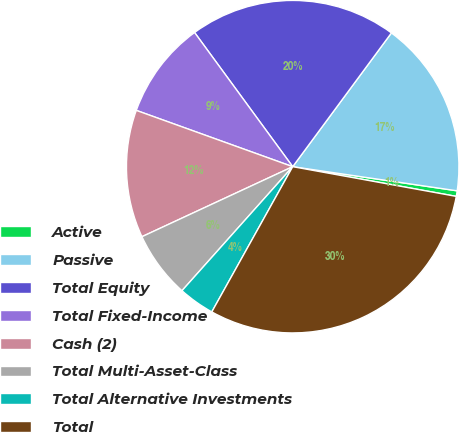Convert chart. <chart><loc_0><loc_0><loc_500><loc_500><pie_chart><fcel>Active<fcel>Passive<fcel>Total Equity<fcel>Total Fixed-Income<fcel>Cash (2)<fcel>Total Multi-Asset-Class<fcel>Total Alternative Investments<fcel>Total<nl><fcel>0.54%<fcel>17.2%<fcel>20.17%<fcel>9.45%<fcel>12.42%<fcel>6.48%<fcel>3.51%<fcel>30.23%<nl></chart> 